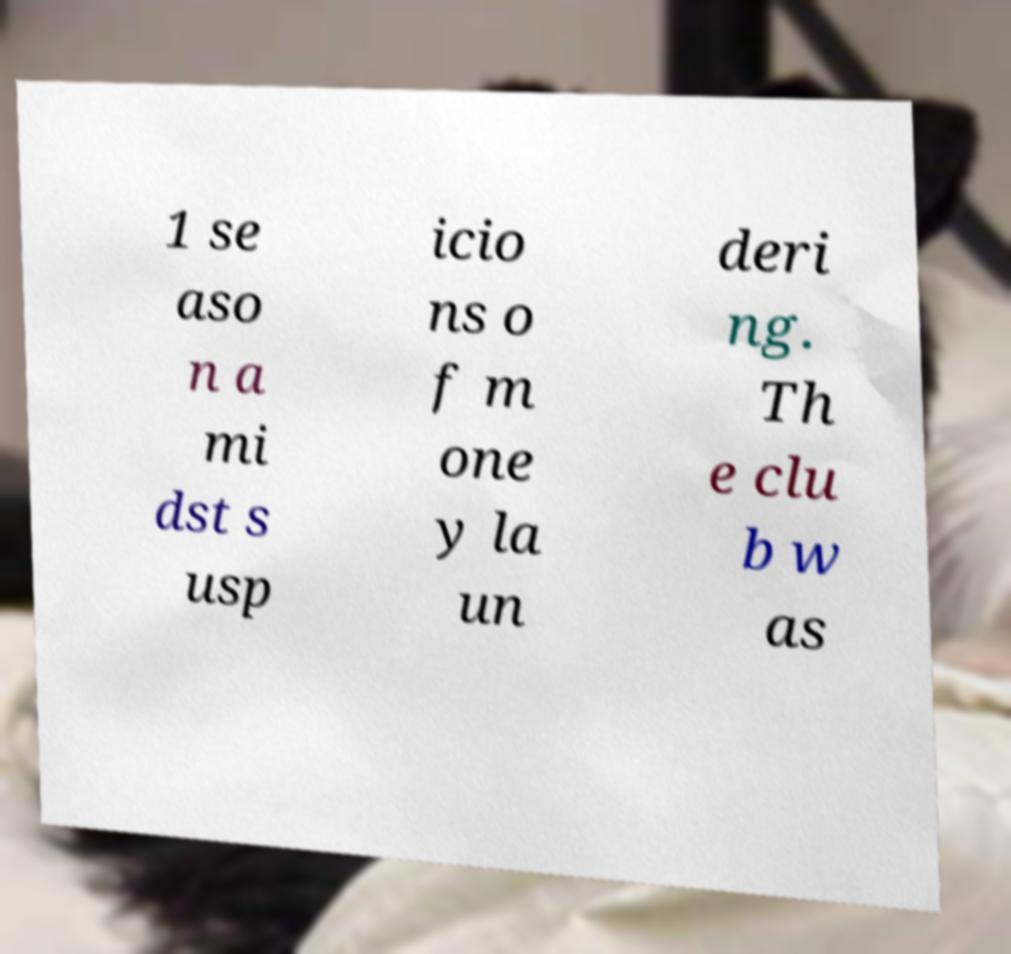Please read and relay the text visible in this image. What does it say? 1 se aso n a mi dst s usp icio ns o f m one y la un deri ng. Th e clu b w as 